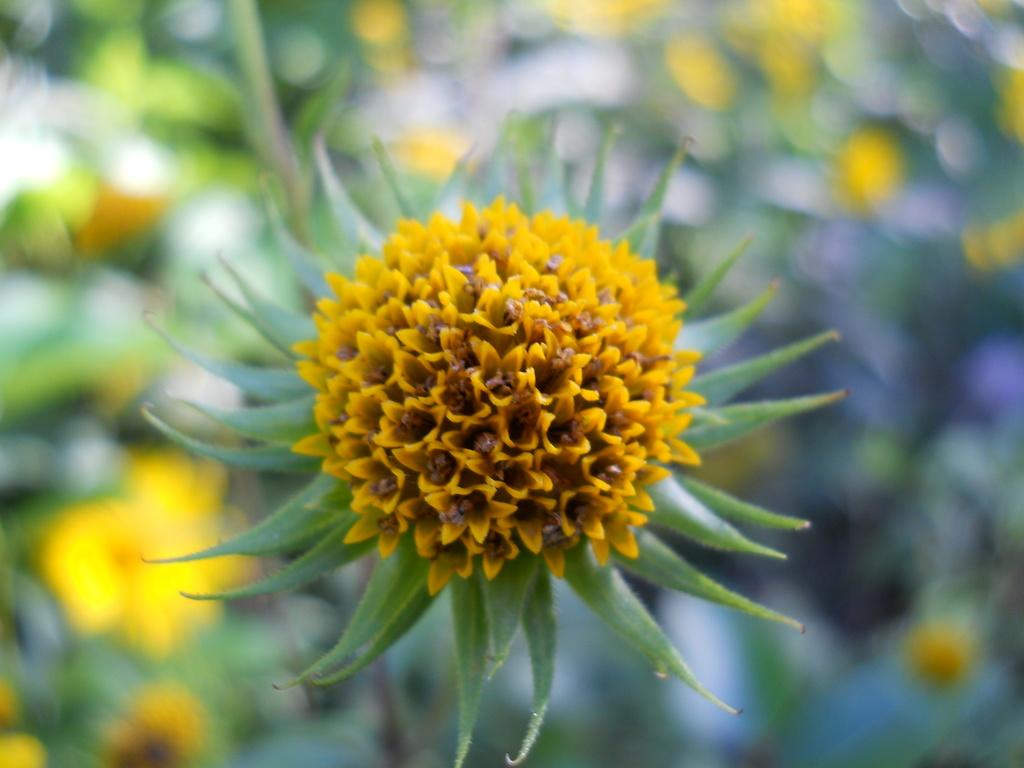What type of plant is in the image? There is an aloe Vera plant in the image. What color is the aloe Vera plant? The aloe Vera plant is green in color. Are there any flowers on the aloe Vera plant? Yes, there are yellow flowers on the aloe Vera plant. How many ladybugs are crawling on the aloe Vera plant in the image? There are no ladybugs present on the aloe Vera plant in the image. What type of cup is being used to water the aloe Vera plant in the image? There is no cup visible in the image, as it only shows the aloe Vera plant with yellow flowers. 